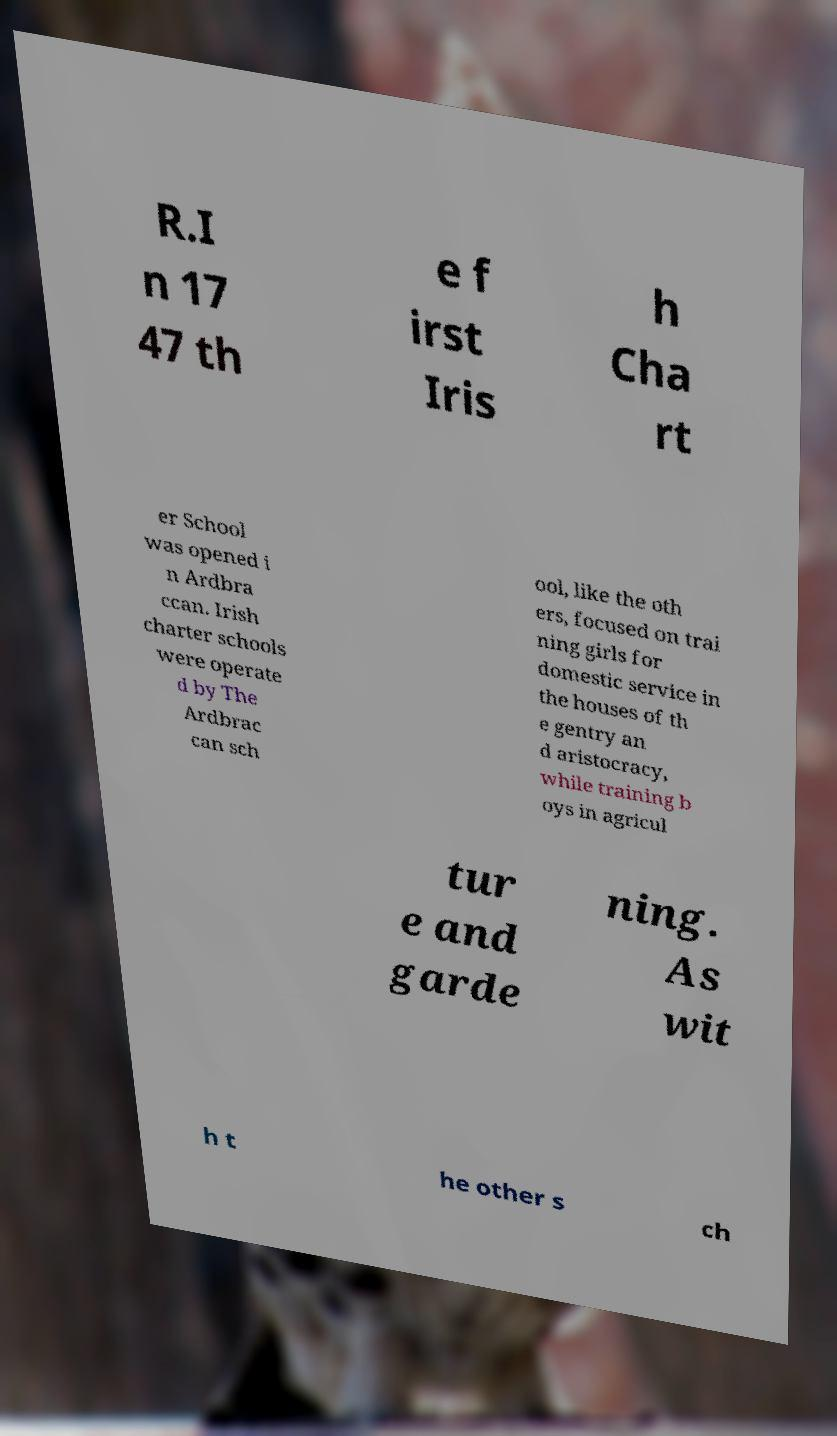For documentation purposes, I need the text within this image transcribed. Could you provide that? R.I n 17 47 th e f irst Iris h Cha rt er School was opened i n Ardbra ccan. Irish charter schools were operate d by The Ardbrac can sch ool, like the oth ers, focused on trai ning girls for domestic service in the houses of th e gentry an d aristocracy, while training b oys in agricul tur e and garde ning. As wit h t he other s ch 